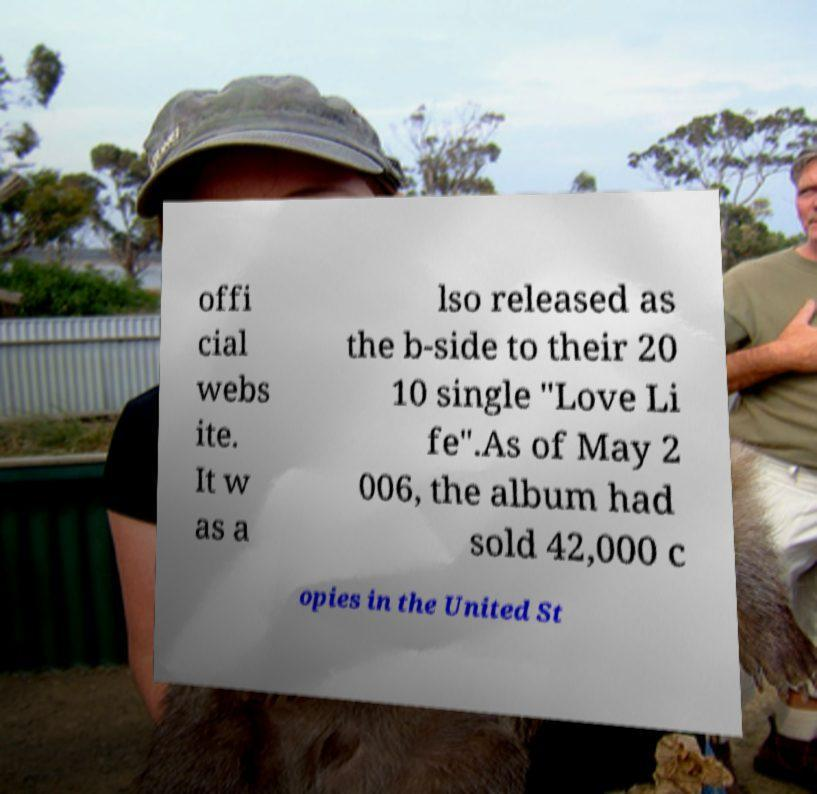Could you assist in decoding the text presented in this image and type it out clearly? offi cial webs ite. It w as a lso released as the b-side to their 20 10 single "Love Li fe".As of May 2 006, the album had sold 42,000 c opies in the United St 